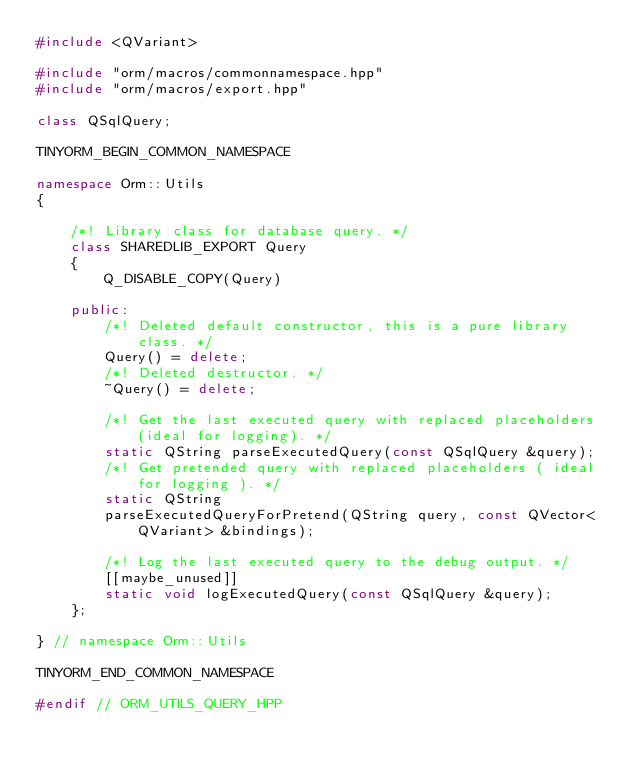Convert code to text. <code><loc_0><loc_0><loc_500><loc_500><_C++_>#include <QVariant>

#include "orm/macros/commonnamespace.hpp"
#include "orm/macros/export.hpp"

class QSqlQuery;

TINYORM_BEGIN_COMMON_NAMESPACE

namespace Orm::Utils
{

    /*! Library class for database query. */
    class SHAREDLIB_EXPORT Query
    {
        Q_DISABLE_COPY(Query)

    public:
        /*! Deleted default constructor, this is a pure library class. */
        Query() = delete;
        /*! Deleted destructor. */
        ~Query() = delete;

        /*! Get the last executed query with replaced placeholders (ideal for logging). */
        static QString parseExecutedQuery(const QSqlQuery &query);
        /*! Get pretended query with replaced placeholders ( ideal for logging ). */
        static QString
        parseExecutedQueryForPretend(QString query, const QVector<QVariant> &bindings);

        /*! Log the last executed query to the debug output. */
        [[maybe_unused]]
        static void logExecutedQuery(const QSqlQuery &query);
    };

} // namespace Orm::Utils

TINYORM_END_COMMON_NAMESPACE

#endif // ORM_UTILS_QUERY_HPP
</code> 